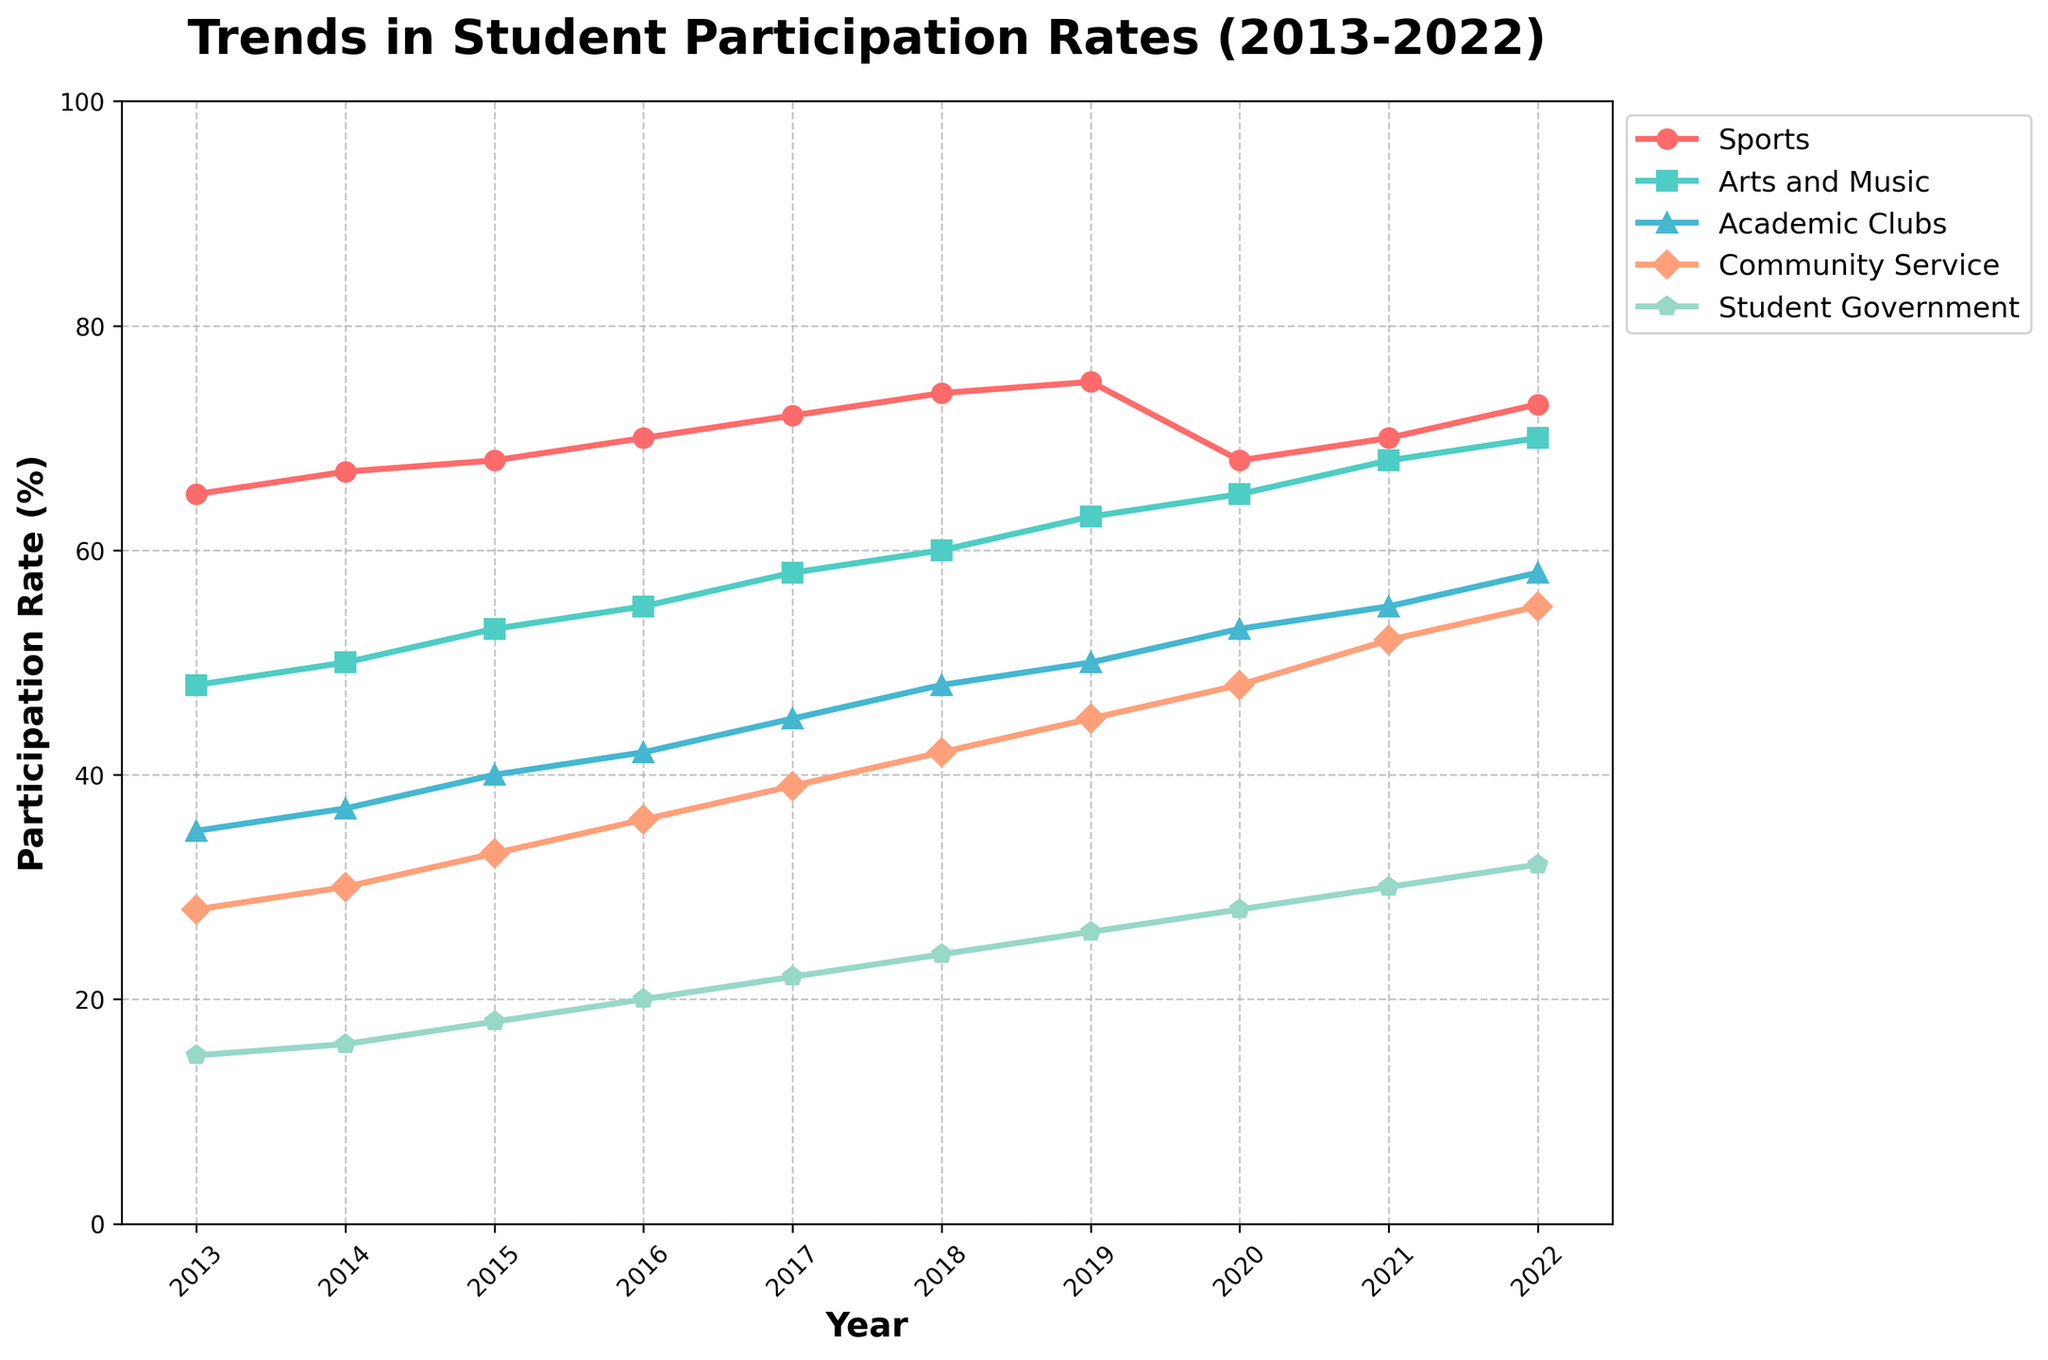What year shows the highest participation in Student Government? To determine the highest participation year for Student Government, look at the line representing Student Government and find its highest point. The apex is in 2022 at 32%.
Answer: 2022 Which activity had the largest increase in participation from 2013 to 2022? Calculate the difference in participation rates between 2013 and 2022 for each activity. Sports grew from 65% to 73%, Arts and Music from 48% to 70%, Academic Clubs from 35% to 58%, Community Service from 28% to 55%, and Student Government from 15% to 32%. The highest increase is for Arts and Music, increasing by 22 percentage points.
Answer: Arts and Music Between 2017 and 2018, which activity saw the highest growth rate? Check the difference between the 2017 and 2018 values for each activity. Sports rose from 72% to 74%, Arts and Music from 58% to 60%, Academic Clubs from 45% to 48%, Community Service from 39% to 42%, and Student Government from 22% to 24%. The largest increase is in Arts and Music and Academic Clubs, each increasing by 3 percentage points.
Answer: Arts and Music and Academic Clubs Which two activities had continuous year-on-year growth from 2013 to 2022? Look at each activity's line plot to see if it ever goes down. Arts and Music and Academic Clubs increase or stay the same every year.
Answer: Arts and Music and Academic Clubs What is the average participation rate of Community Service from 2013 to 2022? Sum the values for Community Service from each year and divide by the number of years (10). (28 + 30 + 33 + 36 + 39 + 42 + 45 + 48 + 52 + 55) / 10 gives an average of 40.8.
Answer: 40.8 Which year had the highest combined participation rate for Arts and Music and Academic Clubs? Sum the rates for Arts and Music and Academic Clubs each year and compare. 2022 has the highest combined rate: Arts and Music (70%) + Academic Clubs (58%) = 128%.
Answer: 2022 During which years did Student Government participation rates match the rates of Community Service? Check the plot to see where the lines for Community Service and Student Government intersect. There's no year where they match exactly.
Answer: None In which year did participation in Sports experience the most significant drop, and what was the percentage drop? Inspect the year-on-year differences in Sports; the most significant drop is from 2019 to 2020, falling from 75% to 68%. The percentage drop is (75 - 68) = 7%.
Answer: 2020 What was the participation rate difference between Sports and Arts and Music in 2018? Subtract Arts and Music participation from Sports participation for 2018. The rates are 74% for Sports and 60% for Arts and Music, so 74 - 60 = 14.
Answer: 14 In 2021, which activity had the smallest disparity in participation rate compared to Academic Clubs? Compare the difference between Academic Clubs (55%) and other activities: Sports (70%) = 15, Arts and Music (68%) = 13, Community Service (52%) = 3, Student Government (30%) = 25. The smallest difference is with Community Service.
Answer: Community Service 